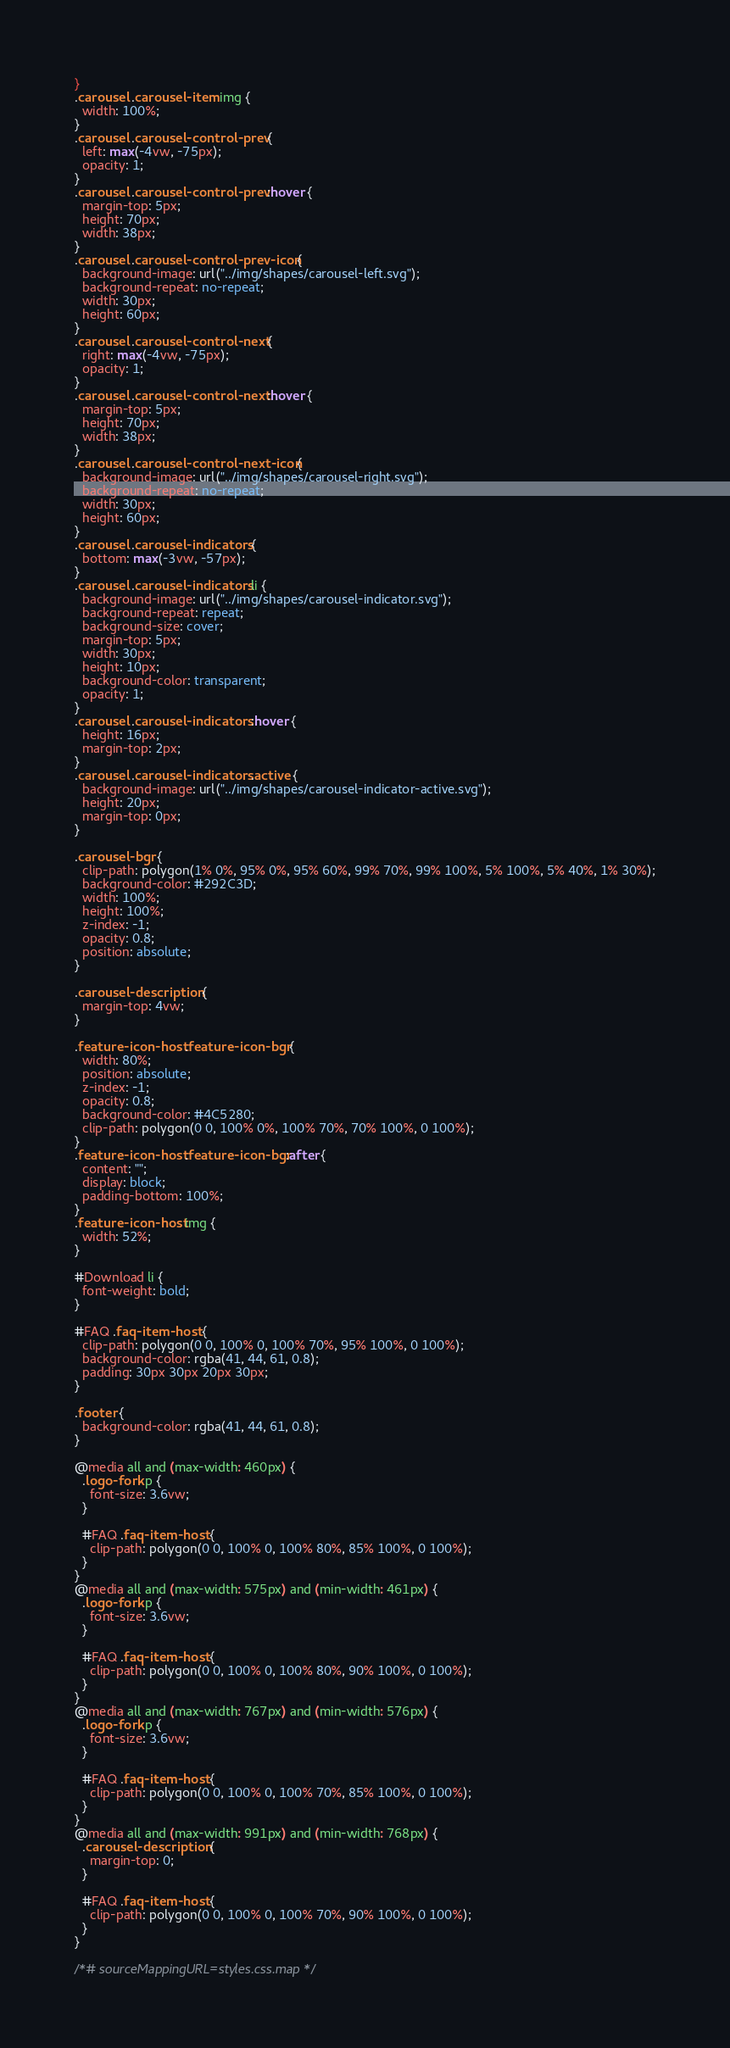Convert code to text. <code><loc_0><loc_0><loc_500><loc_500><_CSS_>}
.carousel .carousel-item img {
  width: 100%;
}
.carousel .carousel-control-prev {
  left: max(-4vw, -75px);
  opacity: 1;
}
.carousel .carousel-control-prev :hover {
  margin-top: 5px;
  height: 70px;
  width: 38px;
}
.carousel .carousel-control-prev-icon {
  background-image: url("../img/shapes/carousel-left.svg");
  background-repeat: no-repeat;
  width: 30px;
  height: 60px;
}
.carousel .carousel-control-next {
  right: max(-4vw, -75px);
  opacity: 1;
}
.carousel .carousel-control-next :hover {
  margin-top: 5px;
  height: 70px;
  width: 38px;
}
.carousel .carousel-control-next-icon {
  background-image: url("../img/shapes/carousel-right.svg");
  background-repeat: no-repeat;
  width: 30px;
  height: 60px;
}
.carousel .carousel-indicators {
  bottom: max(-3vw, -57px);
}
.carousel .carousel-indicators li {
  background-image: url("../img/shapes/carousel-indicator.svg");
  background-repeat: repeat;
  background-size: cover;
  margin-top: 5px;
  width: 30px;
  height: 10px;
  background-color: transparent;
  opacity: 1;
}
.carousel .carousel-indicators :hover {
  height: 16px;
  margin-top: 2px;
}
.carousel .carousel-indicators .active {
  background-image: url("../img/shapes/carousel-indicator-active.svg");
  height: 20px;
  margin-top: 0px;
}

.carousel-bgr {
  clip-path: polygon(1% 0%, 95% 0%, 95% 60%, 99% 70%, 99% 100%, 5% 100%, 5% 40%, 1% 30%);
  background-color: #292C3D;
  width: 100%;
  height: 100%;
  z-index: -1;
  opacity: 0.8;
  position: absolute;
}

.carousel-description {
  margin-top: 4vw;
}

.feature-icon-host .feature-icon-bgr {
  width: 80%;
  position: absolute;
  z-index: -1;
  opacity: 0.8;
  background-color: #4C5280;
  clip-path: polygon(0 0, 100% 0%, 100% 70%, 70% 100%, 0 100%);
}
.feature-icon-host .feature-icon-bgr:after {
  content: "";
  display: block;
  padding-bottom: 100%;
}
.feature-icon-host img {
  width: 52%;
}

#Download li {
  font-weight: bold;
}

#FAQ .faq-item-host {
  clip-path: polygon(0 0, 100% 0, 100% 70%, 95% 100%, 0 100%);
  background-color: rgba(41, 44, 61, 0.8);
  padding: 30px 30px 20px 30px;
}

.footer {
  background-color: rgba(41, 44, 61, 0.8);
}

@media all and (max-width: 460px) {
  .logo-fork p {
    font-size: 3.6vw;
  }

  #FAQ .faq-item-host {
    clip-path: polygon(0 0, 100% 0, 100% 80%, 85% 100%, 0 100%);
  }
}
@media all and (max-width: 575px) and (min-width: 461px) {
  .logo-fork p {
    font-size: 3.6vw;
  }

  #FAQ .faq-item-host {
    clip-path: polygon(0 0, 100% 0, 100% 80%, 90% 100%, 0 100%);
  }
}
@media all and (max-width: 767px) and (min-width: 576px) {
  .logo-fork p {
    font-size: 3.6vw;
  }

  #FAQ .faq-item-host {
    clip-path: polygon(0 0, 100% 0, 100% 70%, 85% 100%, 0 100%);
  }
}
@media all and (max-width: 991px) and (min-width: 768px) {
  .carousel-description {
    margin-top: 0;
  }

  #FAQ .faq-item-host {
    clip-path: polygon(0 0, 100% 0, 100% 70%, 90% 100%, 0 100%);
  }
}

/*# sourceMappingURL=styles.css.map */
</code> 